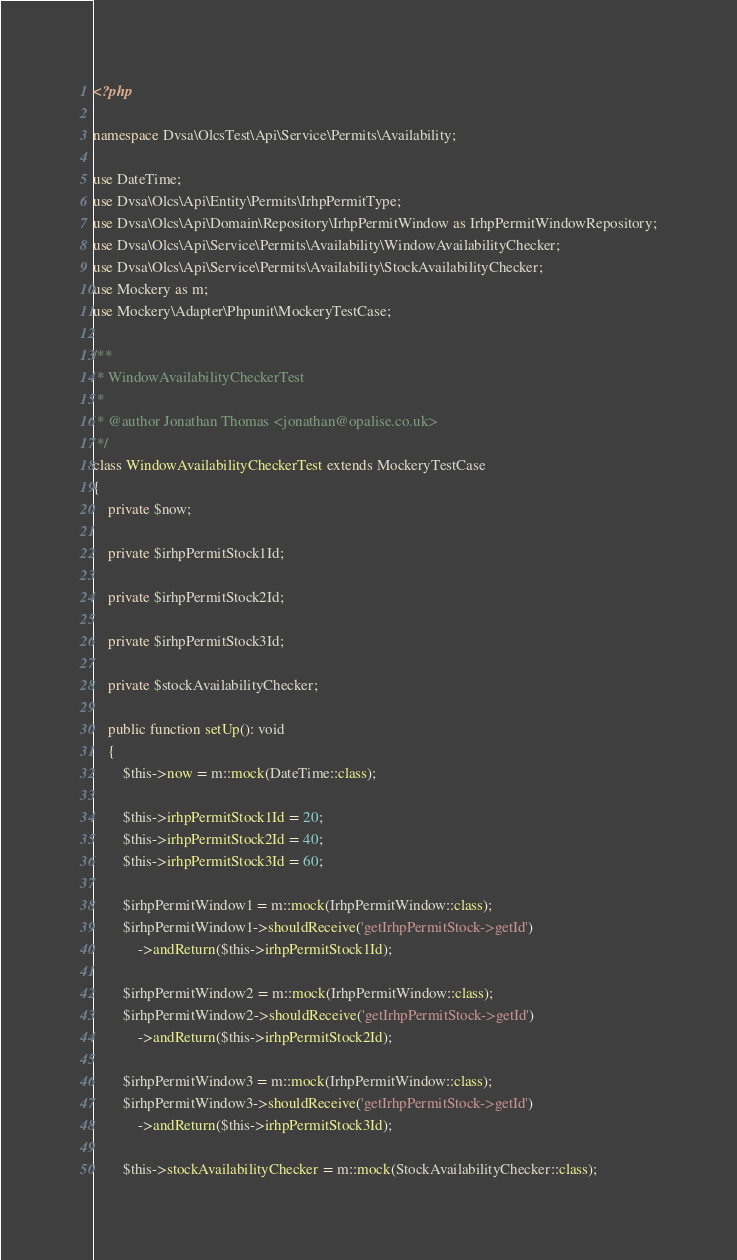<code> <loc_0><loc_0><loc_500><loc_500><_PHP_><?php

namespace Dvsa\OlcsTest\Api\Service\Permits\Availability;

use DateTime;
use Dvsa\Olcs\Api\Entity\Permits\IrhpPermitType;
use Dvsa\Olcs\Api\Domain\Repository\IrhpPermitWindow as IrhpPermitWindowRepository;
use Dvsa\Olcs\Api\Service\Permits\Availability\WindowAvailabilityChecker;
use Dvsa\Olcs\Api\Service\Permits\Availability\StockAvailabilityChecker;
use Mockery as m;
use Mockery\Adapter\Phpunit\MockeryTestCase;

/**
 * WindowAvailabilityCheckerTest
 *
 * @author Jonathan Thomas <jonathan@opalise.co.uk>
 */
class WindowAvailabilityCheckerTest extends MockeryTestCase
{
    private $now;

    private $irhpPermitStock1Id;

    private $irhpPermitStock2Id;

    private $irhpPermitStock3Id;

    private $stockAvailabilityChecker;

    public function setUp(): void
    {
        $this->now = m::mock(DateTime::class);

        $this->irhpPermitStock1Id = 20;
        $this->irhpPermitStock2Id = 40;
        $this->irhpPermitStock3Id = 60;

        $irhpPermitWindow1 = m::mock(IrhpPermitWindow::class);
        $irhpPermitWindow1->shouldReceive('getIrhpPermitStock->getId')
            ->andReturn($this->irhpPermitStock1Id);

        $irhpPermitWindow2 = m::mock(IrhpPermitWindow::class);
        $irhpPermitWindow2->shouldReceive('getIrhpPermitStock->getId')
            ->andReturn($this->irhpPermitStock2Id);

        $irhpPermitWindow3 = m::mock(IrhpPermitWindow::class);
        $irhpPermitWindow3->shouldReceive('getIrhpPermitStock->getId')
            ->andReturn($this->irhpPermitStock3Id);

        $this->stockAvailabilityChecker = m::mock(StockAvailabilityChecker::class);
</code> 